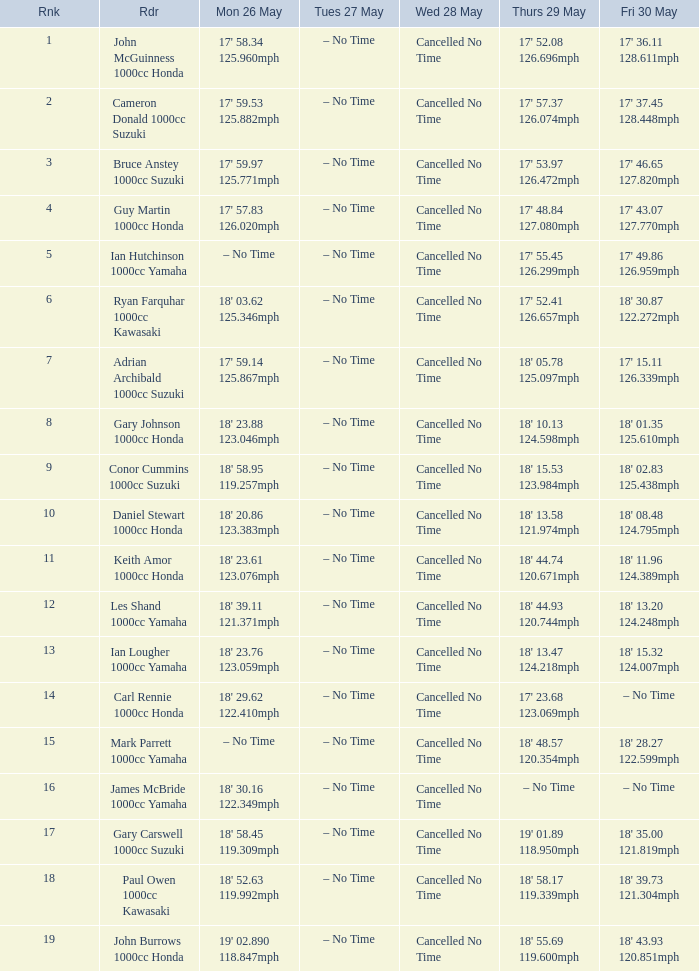What time is mon may 26 and fri may 30 is 18' 28.27 122.599mph? – No Time. 